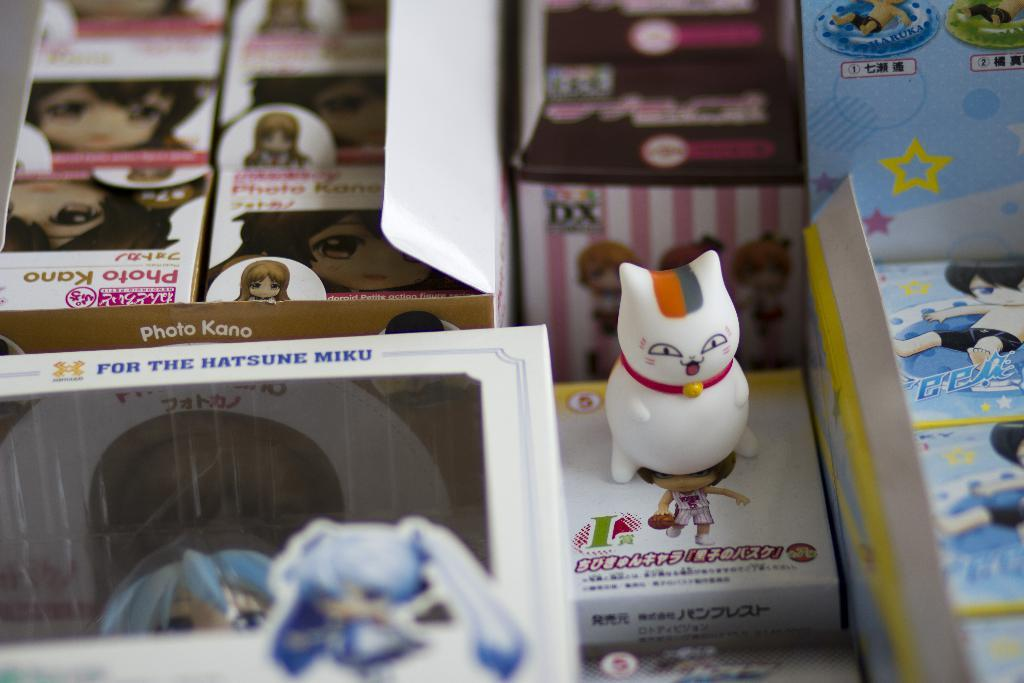Provide a one-sentence caption for the provided image. a small cat figurine with the letter I next to it. 